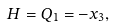<formula> <loc_0><loc_0><loc_500><loc_500>H = Q _ { 1 } = - x _ { 3 } ,</formula> 